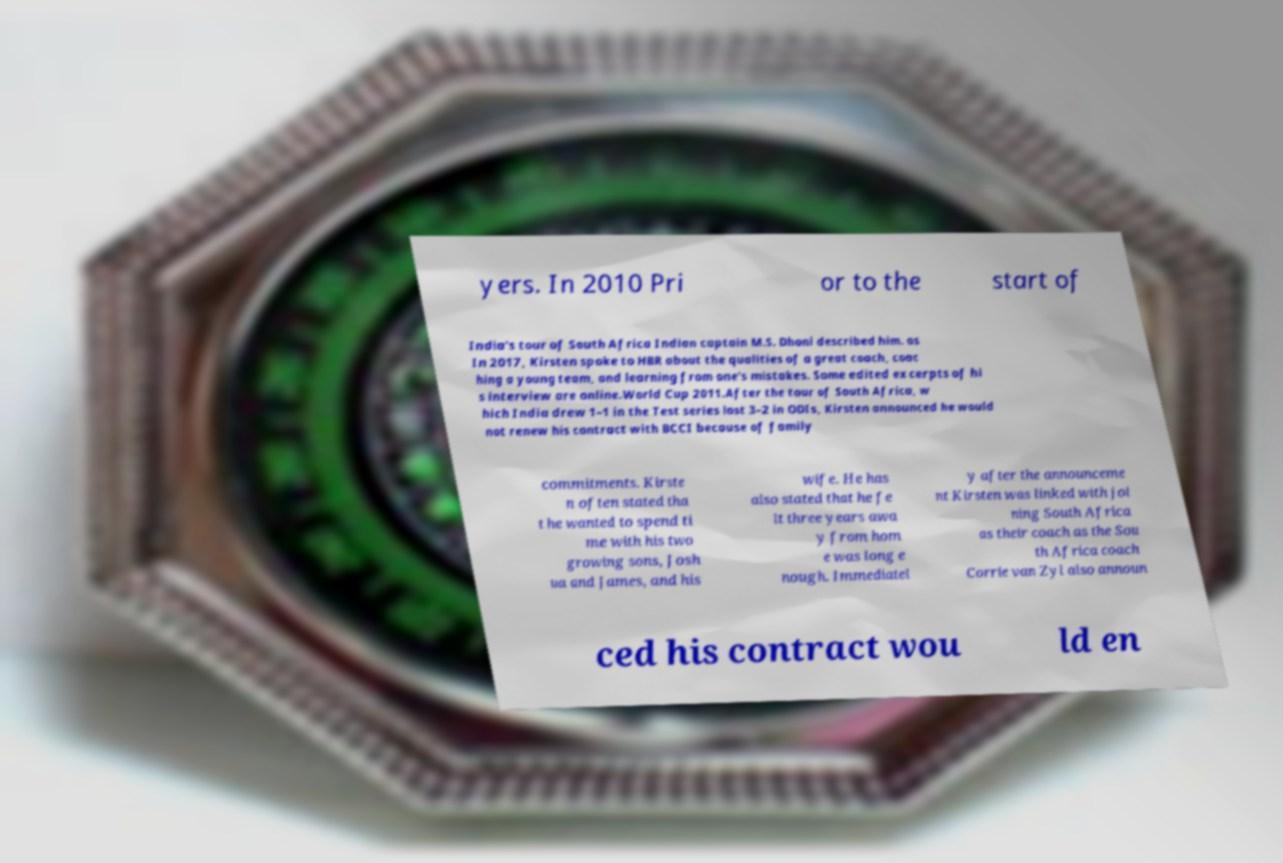Can you read and provide the text displayed in the image?This photo seems to have some interesting text. Can you extract and type it out for me? yers. In 2010 Pri or to the start of India's tour of South Africa Indian captain M.S. Dhoni described him. as In 2017, Kirsten spoke to HBR about the qualities of a great coach, coac hing a young team, and learning from one's mistakes. Some edited excerpts of hi s interview are online.World Cup 2011.After the tour of South Africa, w hich India drew 1–1 in the Test series lost 3–2 in ODIs, Kirsten announced he would not renew his contract with BCCI because of family commitments. Kirste n often stated tha t he wanted to spend ti me with his two growing sons, Josh ua and James, and his wife. He has also stated that he fe lt three years awa y from hom e was long e nough. Immediatel y after the announceme nt Kirsten was linked with joi ning South Africa as their coach as the Sou th Africa coach Corrie van Zyl also announ ced his contract wou ld en 